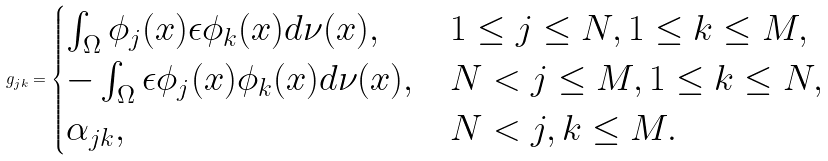<formula> <loc_0><loc_0><loc_500><loc_500>g _ { j k } = \begin{cases} \int _ { \Omega } \phi _ { j } ( x ) \epsilon \phi _ { k } ( x ) d \nu ( x ) , & 1 \leq j \leq N , 1 \leq k \leq M , \\ - \int _ { \Omega } \epsilon \phi _ { j } ( x ) \phi _ { k } ( x ) d \nu ( x ) , & N < j \leq M , 1 \leq k \leq N , \\ \alpha _ { j k } , & N < j , k \leq M . \end{cases}</formula> 